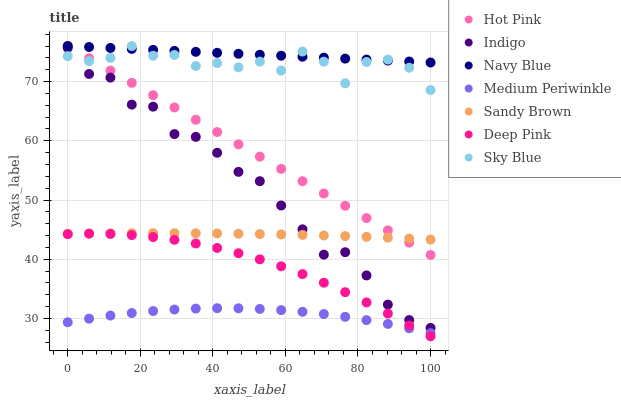Does Medium Periwinkle have the minimum area under the curve?
Answer yes or no. Yes. Does Navy Blue have the maximum area under the curve?
Answer yes or no. Yes. Does Indigo have the minimum area under the curve?
Answer yes or no. No. Does Indigo have the maximum area under the curve?
Answer yes or no. No. Is Hot Pink the smoothest?
Answer yes or no. Yes. Is Sky Blue the roughest?
Answer yes or no. Yes. Is Indigo the smoothest?
Answer yes or no. No. Is Indigo the roughest?
Answer yes or no. No. Does Deep Pink have the lowest value?
Answer yes or no. Yes. Does Indigo have the lowest value?
Answer yes or no. No. Does Sky Blue have the highest value?
Answer yes or no. Yes. Does Indigo have the highest value?
Answer yes or no. No. Is Deep Pink less than Hot Pink?
Answer yes or no. Yes. Is Sky Blue greater than Medium Periwinkle?
Answer yes or no. Yes. Does Deep Pink intersect Medium Periwinkle?
Answer yes or no. Yes. Is Deep Pink less than Medium Periwinkle?
Answer yes or no. No. Is Deep Pink greater than Medium Periwinkle?
Answer yes or no. No. Does Deep Pink intersect Hot Pink?
Answer yes or no. No. 